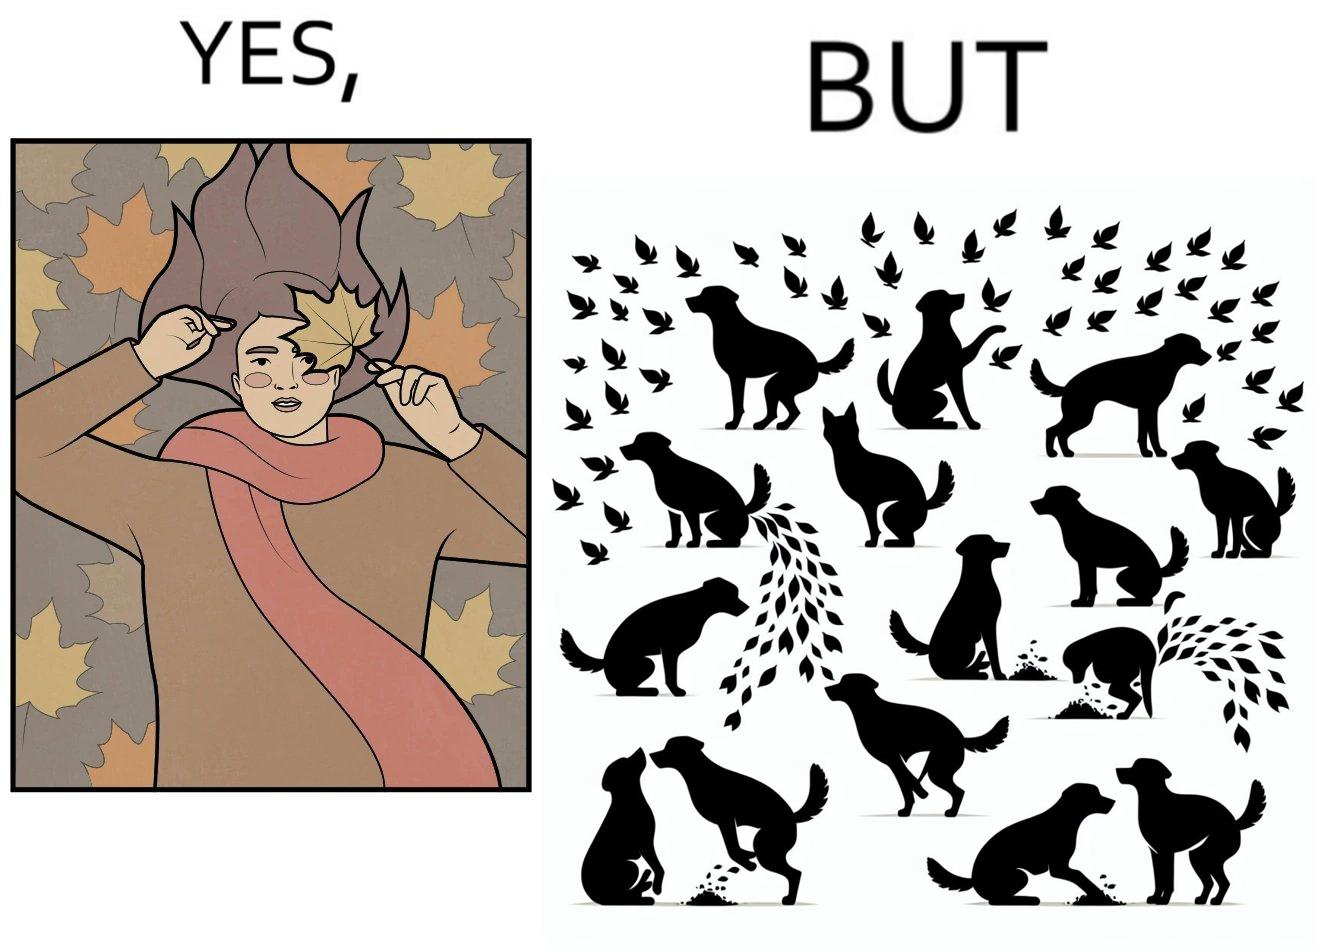Describe what you see in the left and right parts of this image. In the left part of the image: It is a woman holding a leaf over half of her face for a good photo In the right part of the image: It is a few dogs defecating and urinating over leaves 